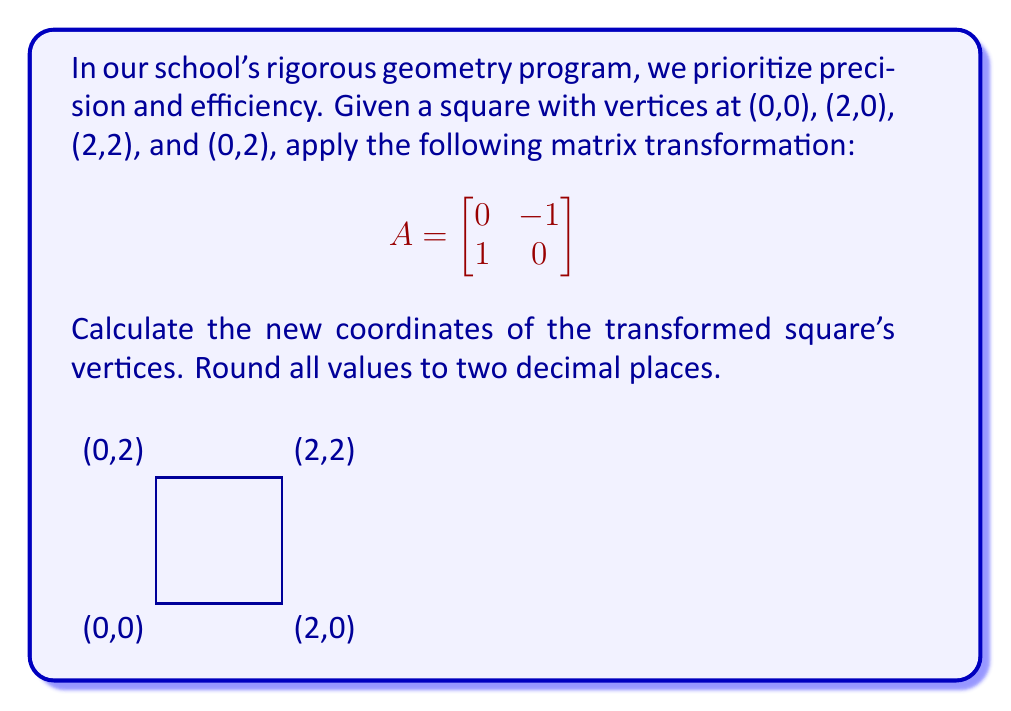Can you answer this question? Let's approach this systematically:

1) The matrix transformation $A = \begin{bmatrix} 0 & -1 \\ 1 & 0 \end{bmatrix}$ represents a 90-degree counterclockwise rotation.

2) To transform a point $(x,y)$, we multiply it by the matrix A:

   $\begin{bmatrix} 0 & -1 \\ 1 & 0 \end{bmatrix} \begin{bmatrix} x \\ y \end{bmatrix} = \begin{bmatrix} -y \\ x \end{bmatrix}$

3) Let's transform each vertex:

   a) (0,0):
      $\begin{bmatrix} 0 & -1 \\ 1 & 0 \end{bmatrix} \begin{bmatrix} 0 \\ 0 \end{bmatrix} = \begin{bmatrix} 0 \\ 0 \end{bmatrix}$

   b) (2,0):
      $\begin{bmatrix} 0 & -1 \\ 1 & 0 \end{bmatrix} \begin{bmatrix} 2 \\ 0 \end{bmatrix} = \begin{bmatrix} 0 \\ 2 \end{bmatrix}$

   c) (2,2):
      $\begin{bmatrix} 0 & -1 \\ 1 & 0 \end{bmatrix} \begin{bmatrix} 2 \\ 2 \end{bmatrix} = \begin{bmatrix} -2 \\ 2 \end{bmatrix}$

   d) (0,2):
      $\begin{bmatrix} 0 & -1 \\ 1 & 0 \end{bmatrix} \begin{bmatrix} 0 \\ 2 \end{bmatrix} = \begin{bmatrix} -2 \\ 0 \end{bmatrix}$

4) Rounding to two decimal places (which is trivial in this case as all values are integers):

   (0.00, 0.00), (0.00, 2.00), (-2.00, 2.00), (-2.00, 0.00)
Answer: (0.00, 0.00), (0.00, 2.00), (-2.00, 2.00), (-2.00, 0.00) 